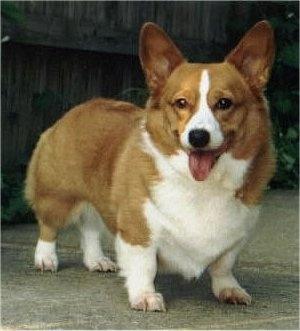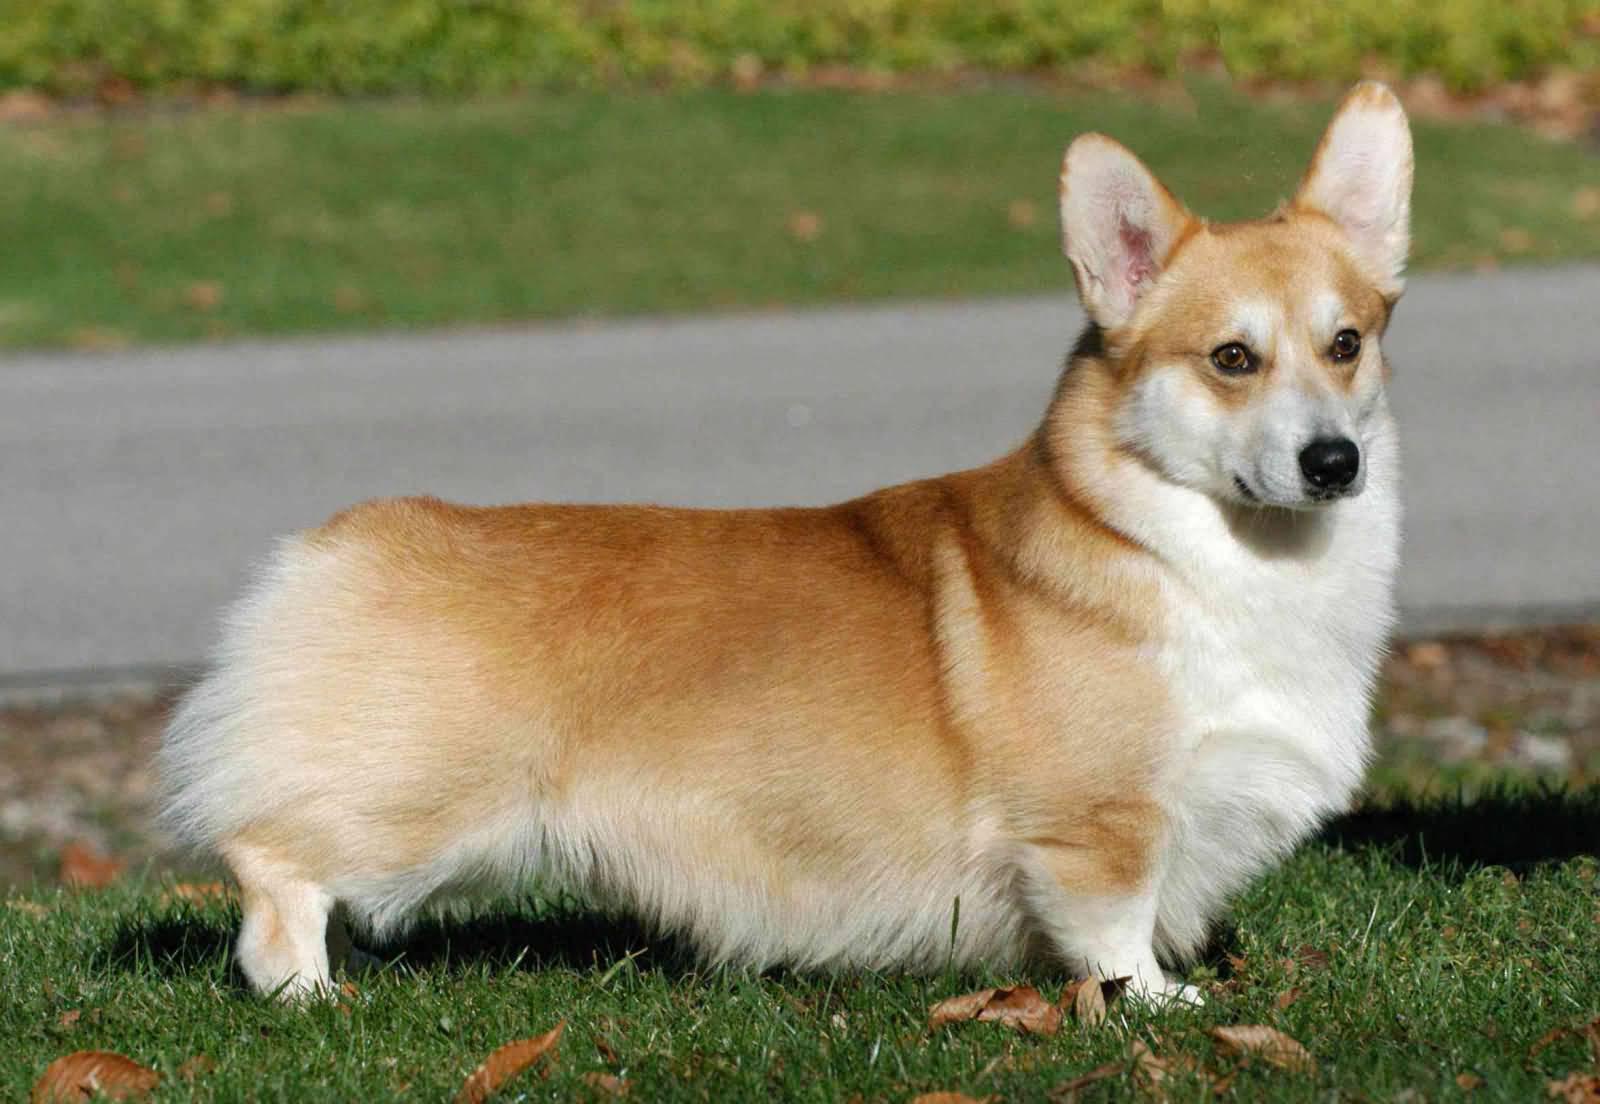The first image is the image on the left, the second image is the image on the right. Evaluate the accuracy of this statement regarding the images: "The left image features a camera-gazing corgi with its tongue hanging out, and the right image shows a corgi standing rightward in profile, with its head turned forward.". Is it true? Answer yes or no. Yes. The first image is the image on the left, the second image is the image on the right. Considering the images on both sides, is "In the right image, a corgi's body is facing right while it's face is towards the camera." valid? Answer yes or no. Yes. 